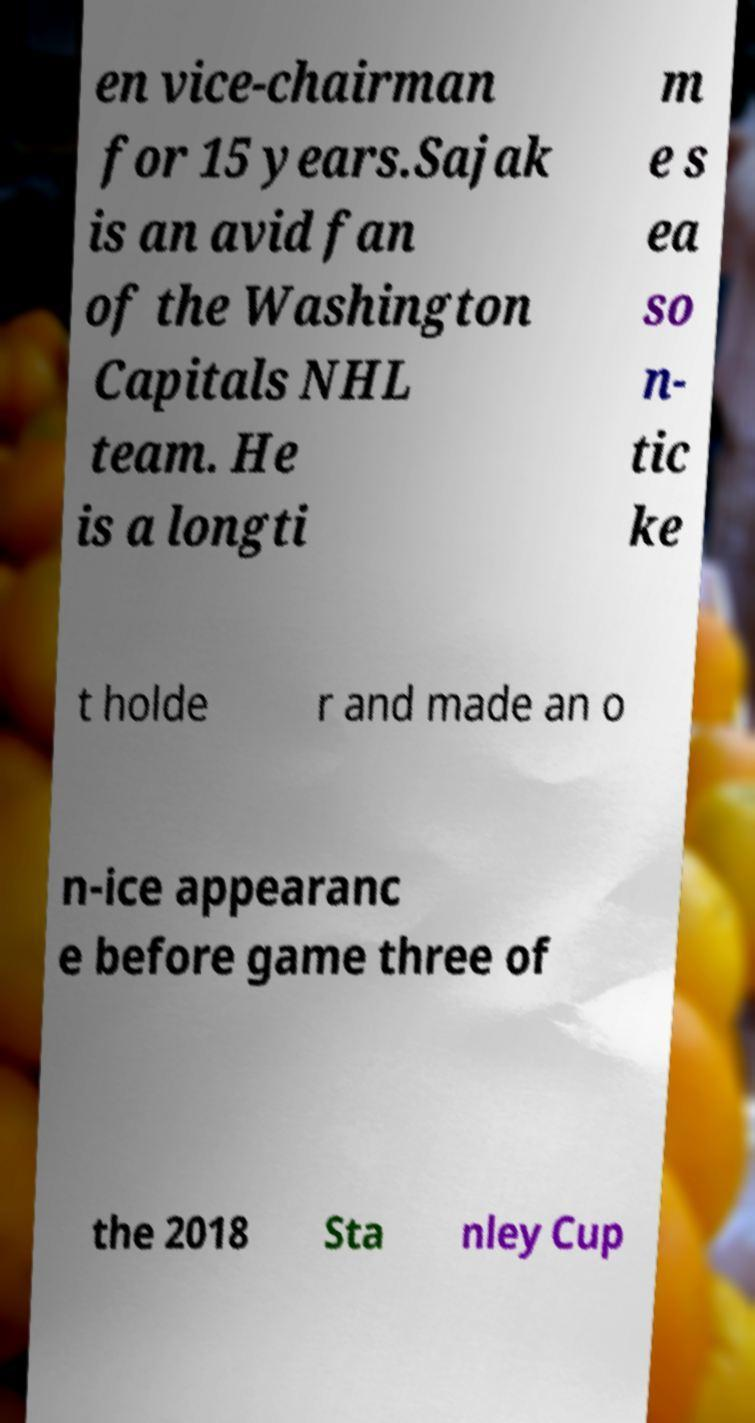Can you read and provide the text displayed in the image?This photo seems to have some interesting text. Can you extract and type it out for me? en vice-chairman for 15 years.Sajak is an avid fan of the Washington Capitals NHL team. He is a longti m e s ea so n- tic ke t holde r and made an o n-ice appearanc e before game three of the 2018 Sta nley Cup 